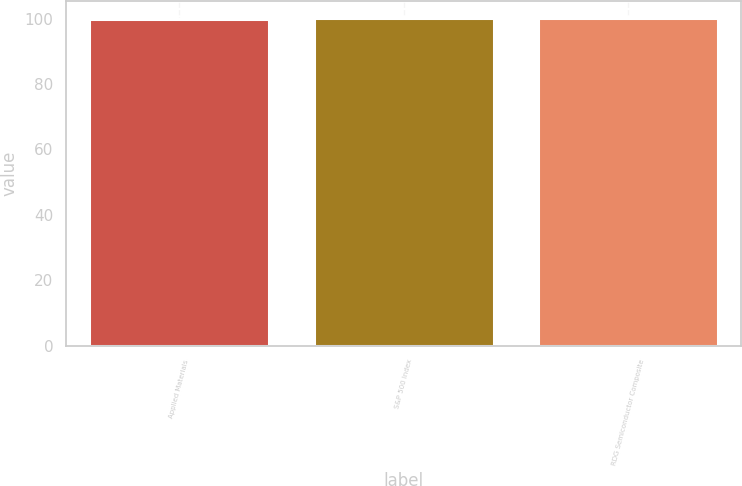<chart> <loc_0><loc_0><loc_500><loc_500><bar_chart><fcel>Applied Materials<fcel>S&P 500 Index<fcel>RDG Semiconductor Composite<nl><fcel>100<fcel>100.1<fcel>100.2<nl></chart> 